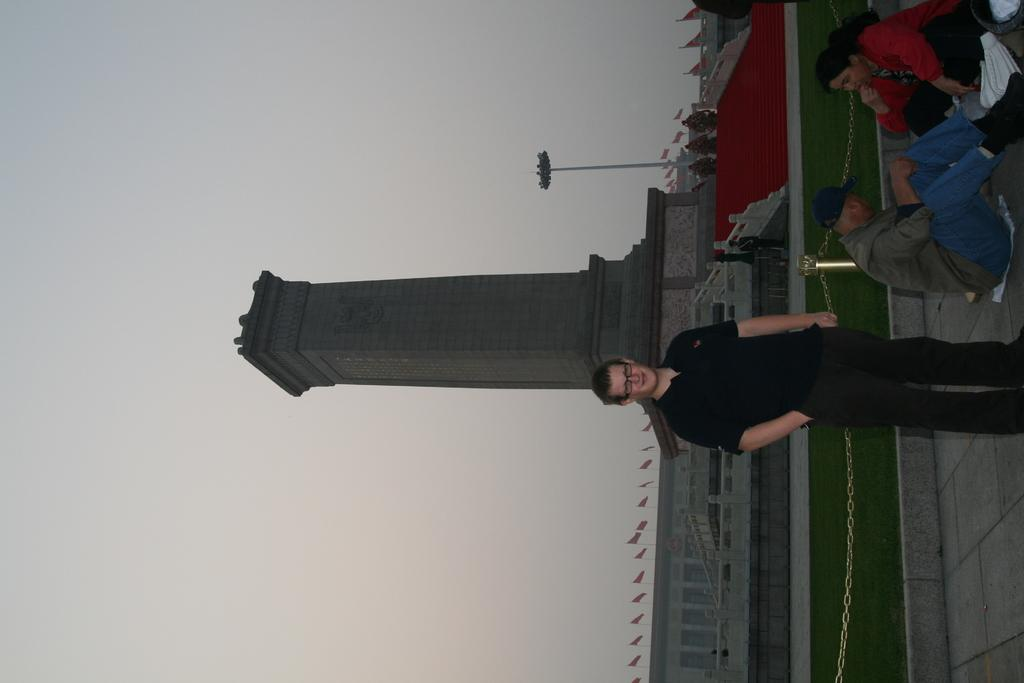Who is the main subject in the image? There is a man in the image. What is the man wearing? The man is wearing a black dress. What is the man doing in the image? The man is standing. Who else is present in the image? There are two persons sitting beside the man. What can be seen in the background of the image? There is a building and flags in the background of the image. What is the limit of the father's patience in the image? There is no father present in the image, and therefore no information about his patience can be determined. 